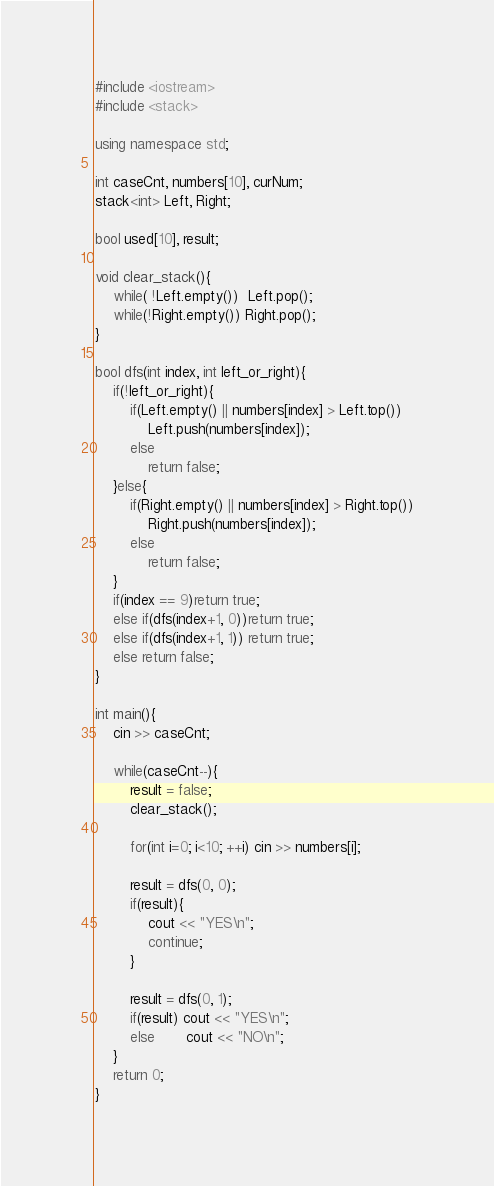Convert code to text. <code><loc_0><loc_0><loc_500><loc_500><_C++_>#include <iostream>
#include <stack>

using namespace std;

int caseCnt, numbers[10], curNum;
stack<int> Left, Right;

bool used[10], result;

void clear_stack(){
    while( !Left.empty())  Left.pop();
    while(!Right.empty()) Right.pop();
}

bool dfs(int index, int left_or_right){
    if(!left_or_right){
        if(Left.empty() || numbers[index] > Left.top())
            Left.push(numbers[index]);
        else
            return false;
    }else{
        if(Right.empty() || numbers[index] > Right.top())
            Right.push(numbers[index]);
        else
            return false;
    }
    if(index == 9)return true;
    else if(dfs(index+1, 0))return true;
    else if(dfs(index+1, 1)) return true;
    else return false;
}

int main(){
    cin >> caseCnt;

    while(caseCnt--){
        result = false;
        clear_stack();

        for(int i=0; i<10; ++i) cin >> numbers[i];

        result = dfs(0, 0);
        if(result){
            cout << "YES\n";
            continue;
        }

        result = dfs(0, 1);
        if(result) cout << "YES\n";
        else       cout << "NO\n";
    }
    return 0;
}

</code> 